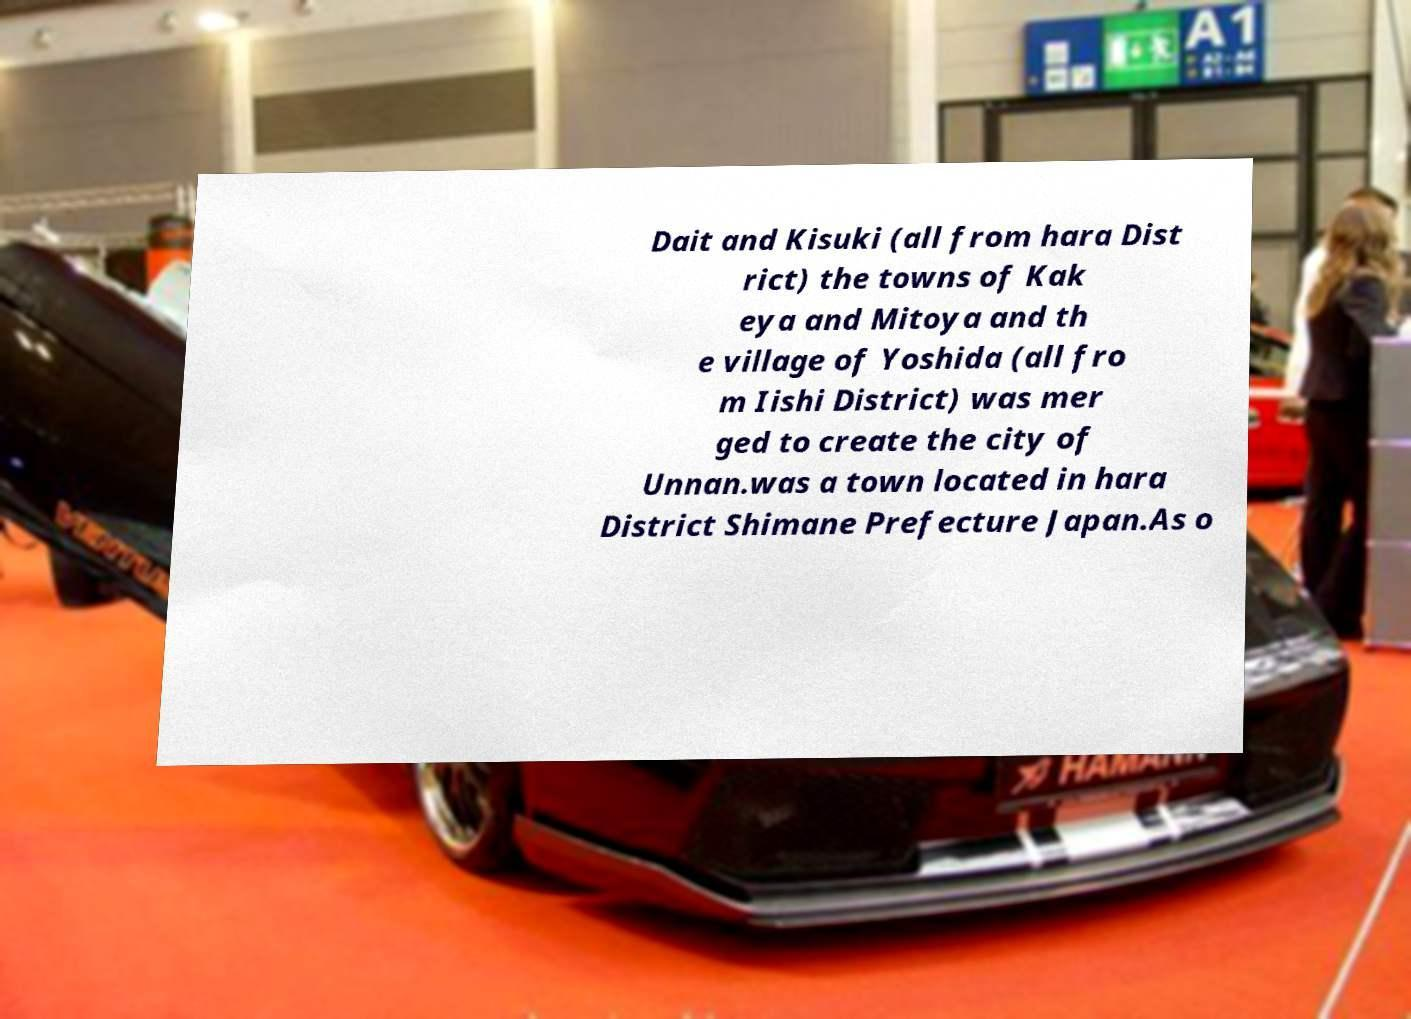What messages or text are displayed in this image? I need them in a readable, typed format. Dait and Kisuki (all from hara Dist rict) the towns of Kak eya and Mitoya and th e village of Yoshida (all fro m Iishi District) was mer ged to create the city of Unnan.was a town located in hara District Shimane Prefecture Japan.As o 